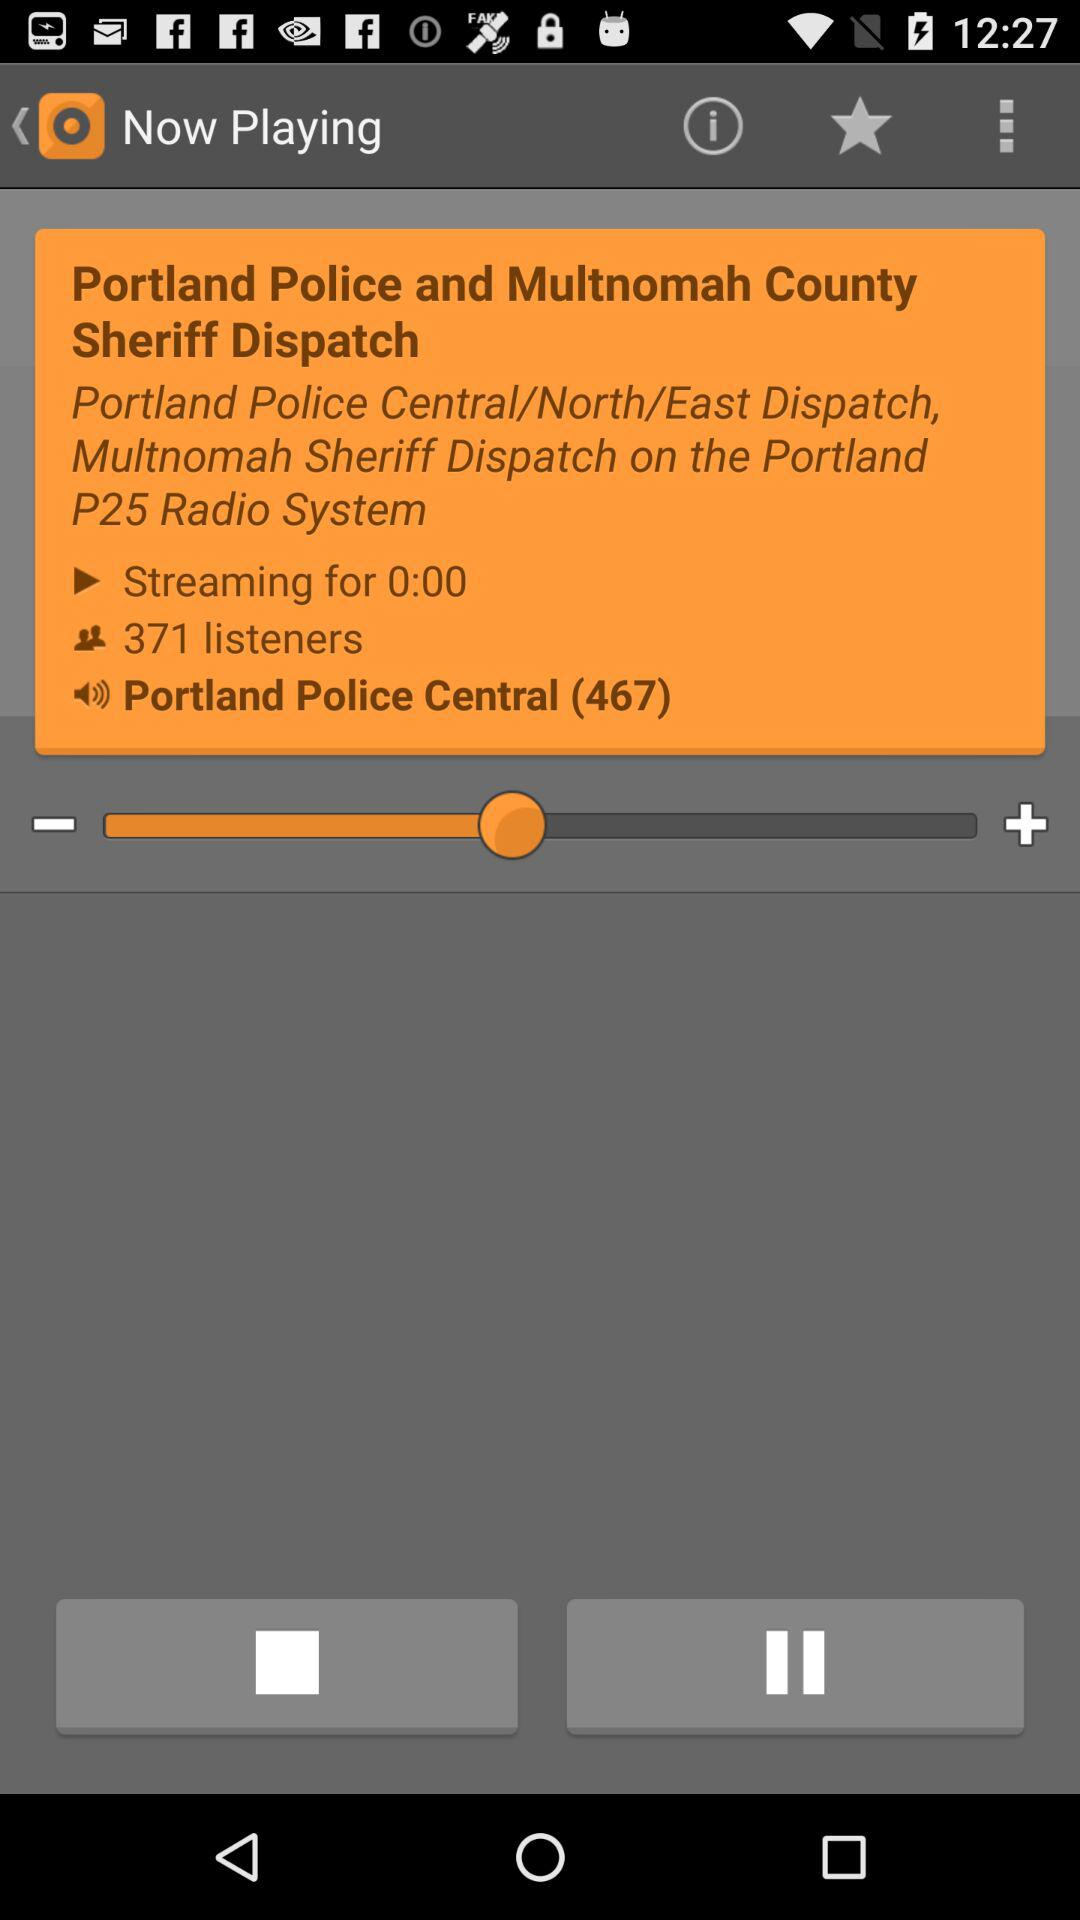What's the stream time? The stream time is 0:00. 